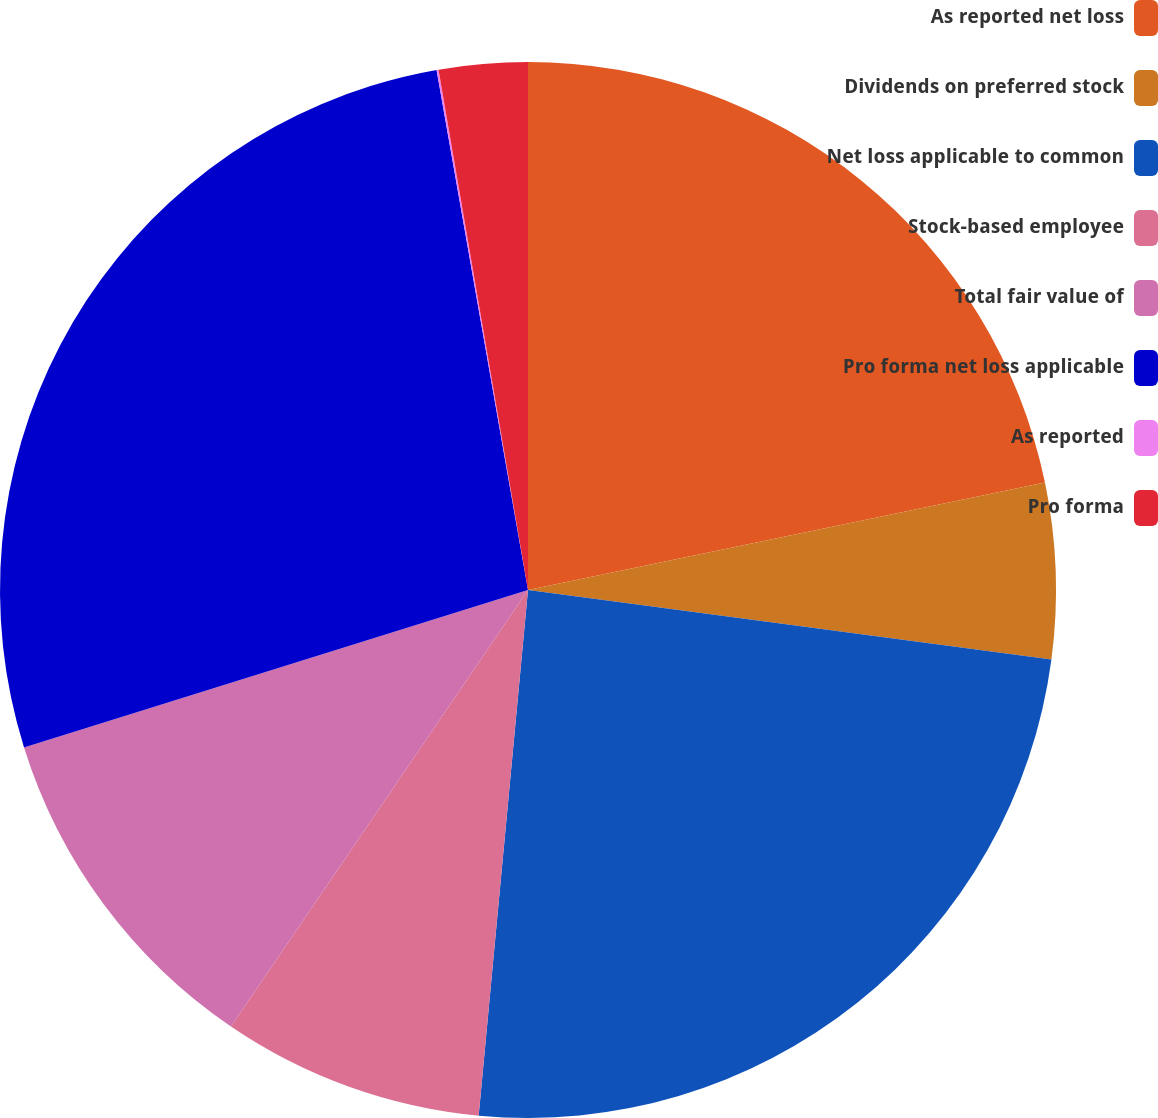Convert chart. <chart><loc_0><loc_0><loc_500><loc_500><pie_chart><fcel>As reported net loss<fcel>Dividends on preferred stock<fcel>Net loss applicable to common<fcel>Stock-based employee<fcel>Total fair value of<fcel>Pro forma net loss applicable<fcel>As reported<fcel>Pro forma<nl><fcel>21.74%<fcel>5.36%<fcel>24.39%<fcel>8.02%<fcel>10.67%<fcel>27.05%<fcel>0.06%<fcel>2.71%<nl></chart> 